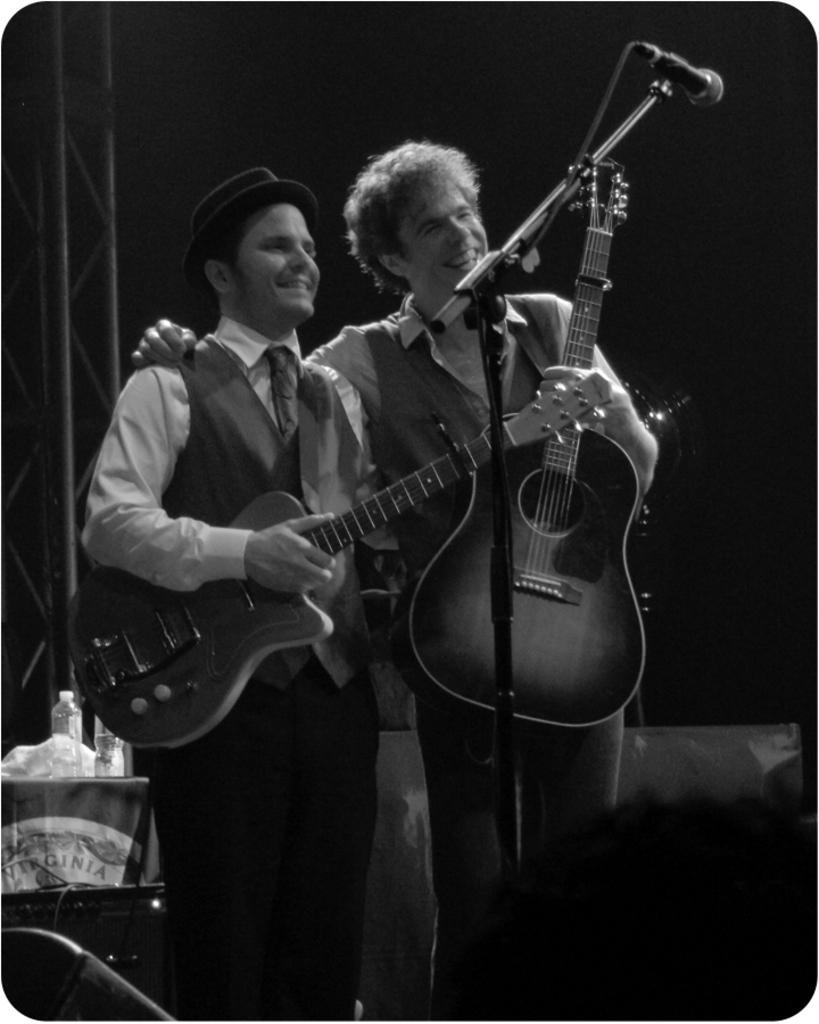Please provide a concise description of this image. In the center of the image there are two people standing. They are holding guitars in their hands. There is a mic placed before them. In the background there is a table. On the table there are bottles and covers. 